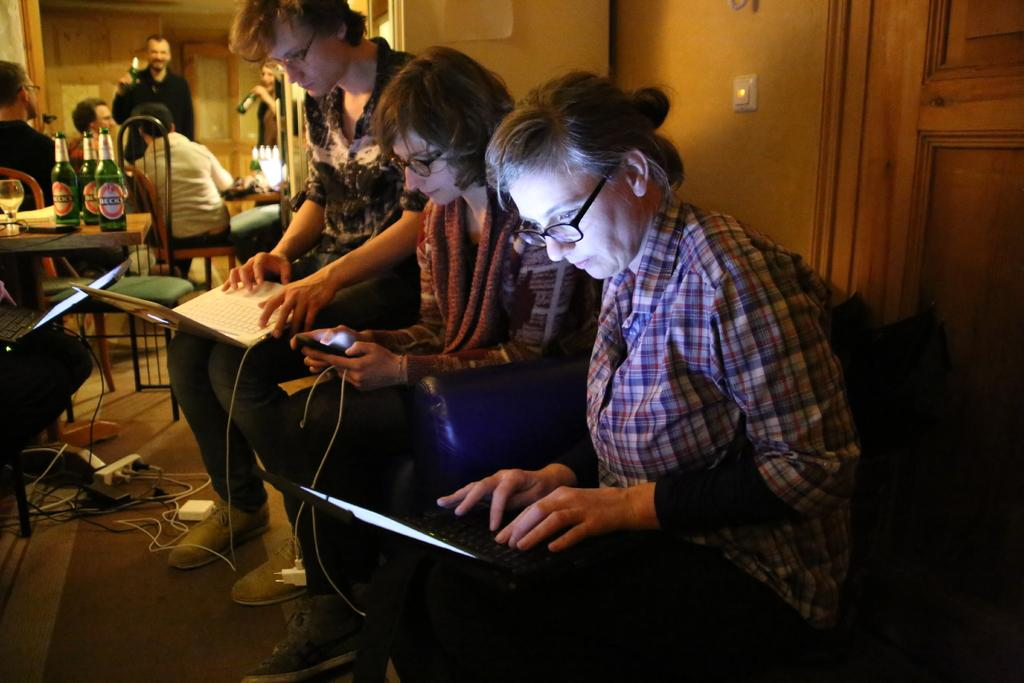What are the persons in the image doing? The persons in the image are sitting and operating a laptop. What can be seen on the table in the background? There are bottles on a table in the background. What is the activity of the people in the background? There are people sitting in the background. What type of door is visible in the image? There is a wooden door visible in the image. What type of calculator is being used by the manager in the image? There is no manager or calculator present in the image. 